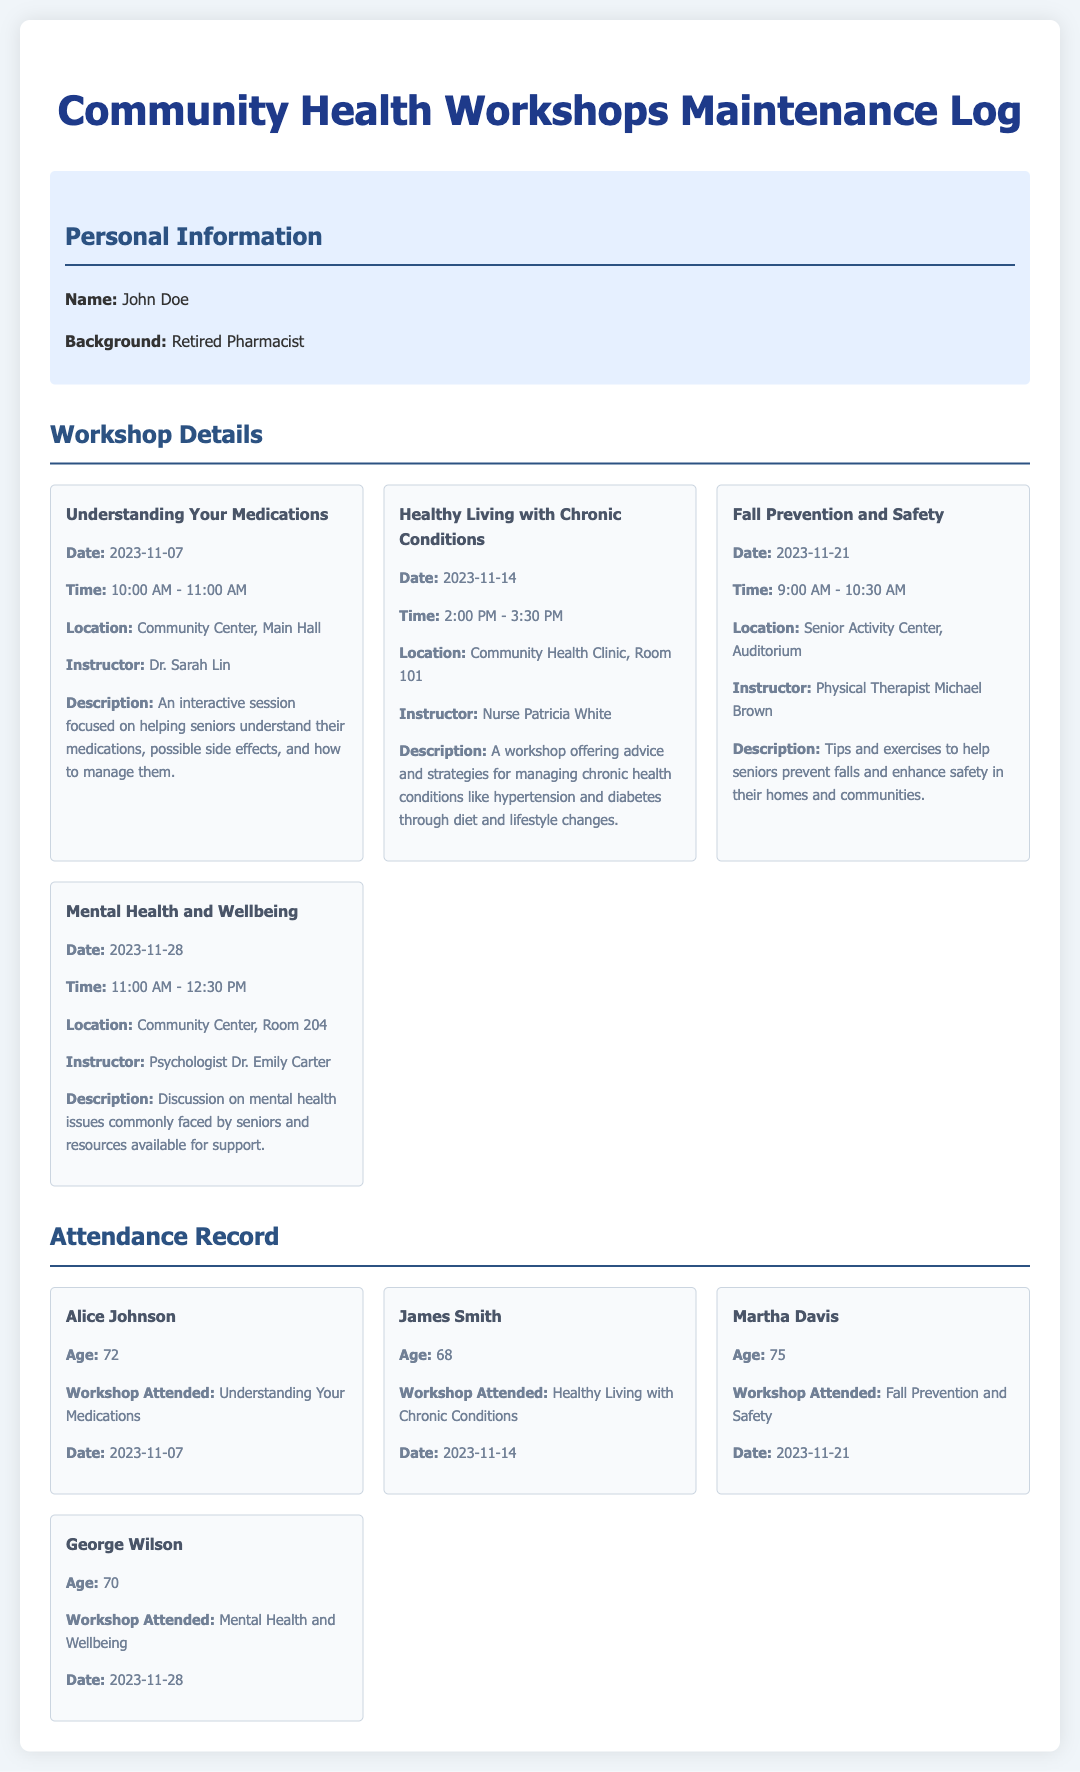what is the date of the workshop "Understanding Your Medications"? The date for the workshop "Understanding Your Medications" is explicitly mentioned in the document as November 7, 2023.
Answer: November 7, 2023 who is the instructor for "Mental Health and Wellbeing"? The instructor for the "Mental Health and Wellbeing" workshop is identified in the document as psychologist Dr. Emily Carter.
Answer: Dr. Emily Carter how many workshops are scheduled in November 2023? The document lists four workshops scheduled for November, specifically dated from the 7th to the 28th.
Answer: 4 what is the duration of the "Healthy Living with Chronic Conditions" workshop? The document states that the "Healthy Living with Chronic Conditions" workshop runs from 2:00 PM to 3:30 PM, indicating a duration of 1 hour and 30 minutes.
Answer: 1 hour and 30 minutes who attended the "Fall Prevention and Safety" workshop? According to the attendance record, Martha Davis attended the "Fall Prevention and Safety" workshop on November 21, 2023.
Answer: Martha Davis how many attendees are listed in the attendance record? The attendance record in the document shows a total of four attendees with their details presented.
Answer: 4 where is the "Healthy Living with Chronic Conditions" workshop held? The location for the "Healthy Living with Chronic Conditions" workshop is specified as Community Health Clinic, Room 101 in the document.
Answer: Community Health Clinic, Room 101 what is the primary focus of the workshop "Understanding Your Medications"? The document describes the "Understanding Your Medications" workshop as being focused on helping seniors understand their medications and possible side effects.
Answer: Helping seniors understand their medications what age is George Wilson? The document states that George Wilson is 70 years old as per the attendance record.
Answer: 70 